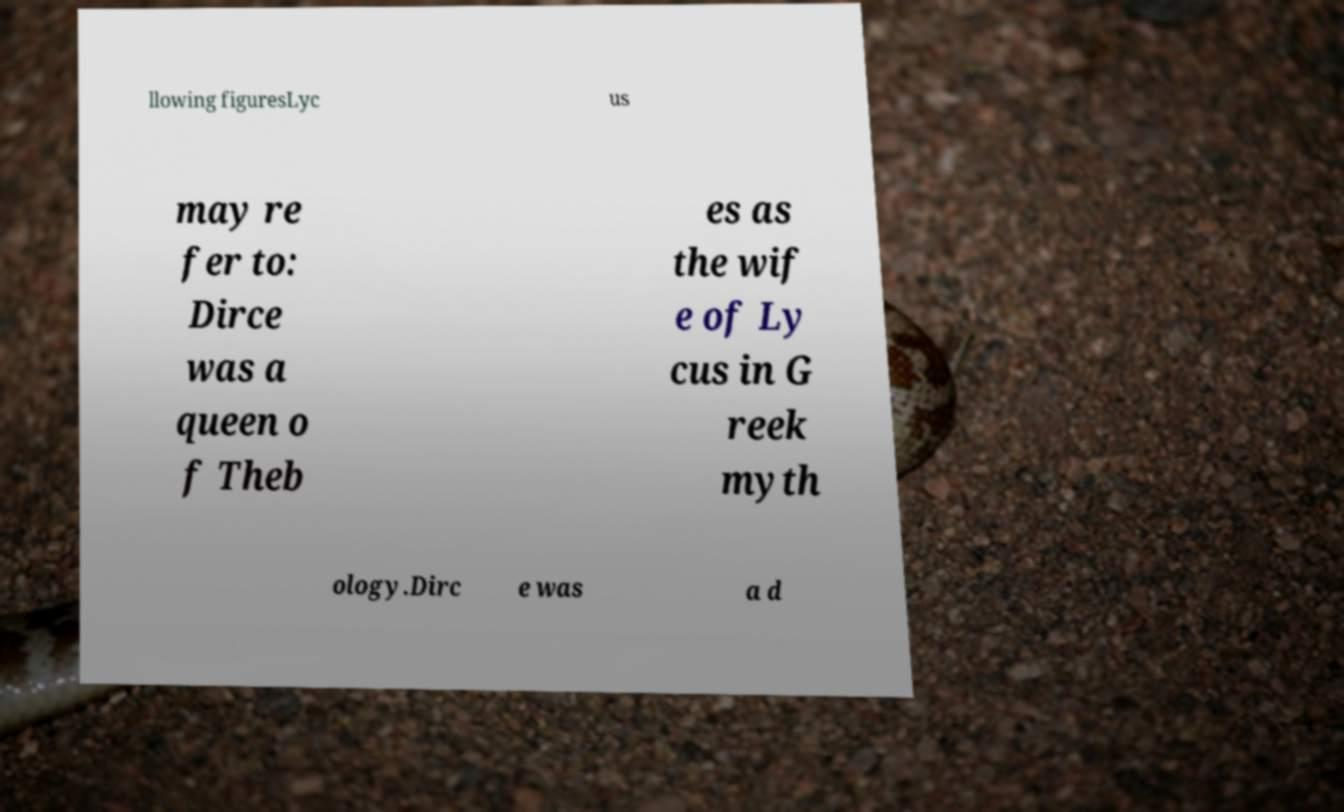I need the written content from this picture converted into text. Can you do that? llowing figuresLyc us may re fer to: Dirce was a queen o f Theb es as the wif e of Ly cus in G reek myth ology.Dirc e was a d 